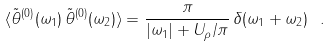Convert formula to latex. <formula><loc_0><loc_0><loc_500><loc_500>\langle \tilde { \theta } ^ { ( 0 ) } ( \omega _ { 1 } ) \, \tilde { \theta } ^ { ( 0 ) } ( \omega _ { 2 } ) \rangle = \frac { \pi } { | \omega _ { 1 } | + U _ { \rho } / \pi } \, \delta ( \omega _ { 1 } + \omega _ { 2 } ) \ .</formula> 